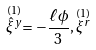Convert formula to latex. <formula><loc_0><loc_0><loc_500><loc_500>\stackrel { ( 1 ) } { \hat { \xi } ^ { y } } = - \frac { \ell \phi } { 3 } , \stackrel { ( 1 ) } { \xi ^ { r } }</formula> 